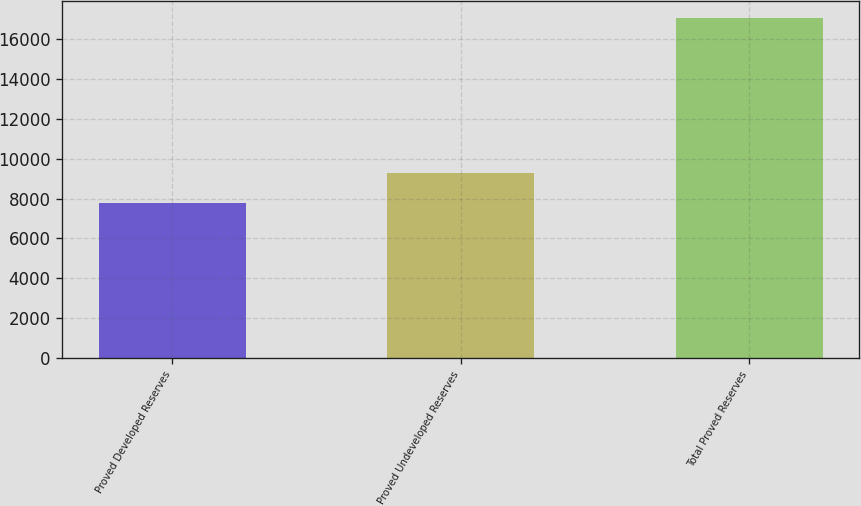Convert chart to OTSL. <chart><loc_0><loc_0><loc_500><loc_500><bar_chart><fcel>Proved Developed Reserves<fcel>Proved Undeveloped Reserves<fcel>Total Proved Reserves<nl><fcel>7757<fcel>9288<fcel>17045<nl></chart> 